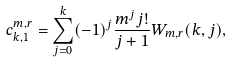<formula> <loc_0><loc_0><loc_500><loc_500>c _ { k , 1 } ^ { m , r } = \sum _ { j = 0 } ^ { k } ( - 1 ) ^ { j } \frac { m ^ { j } j ! } { j + 1 } W _ { m , r } ( k , j ) ,</formula> 